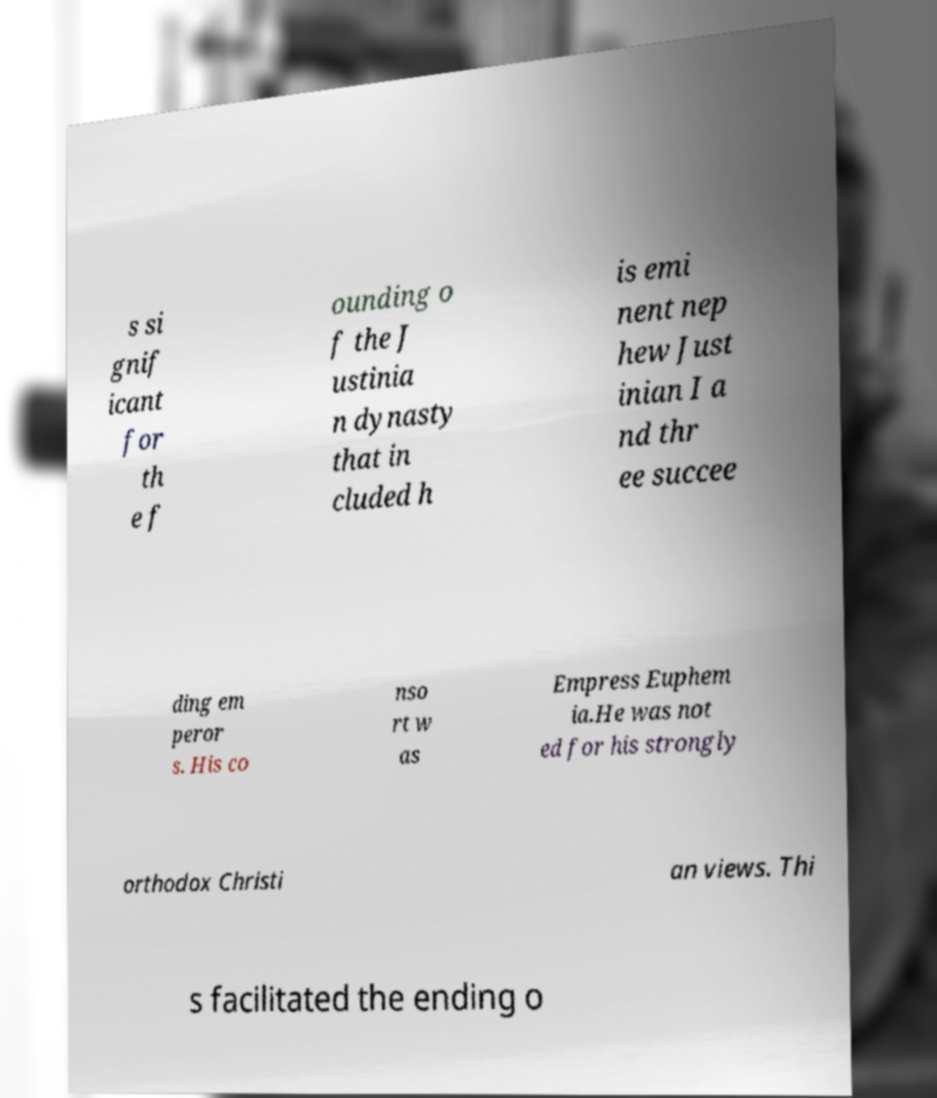Please read and relay the text visible in this image. What does it say? s si gnif icant for th e f ounding o f the J ustinia n dynasty that in cluded h is emi nent nep hew Just inian I a nd thr ee succee ding em peror s. His co nso rt w as Empress Euphem ia.He was not ed for his strongly orthodox Christi an views. Thi s facilitated the ending o 